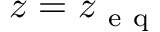<formula> <loc_0><loc_0><loc_500><loc_500>z = z _ { e q }</formula> 